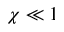<formula> <loc_0><loc_0><loc_500><loc_500>\chi \ll 1</formula> 